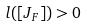<formula> <loc_0><loc_0><loc_500><loc_500>l ( [ J _ { F } ] ) > 0</formula> 